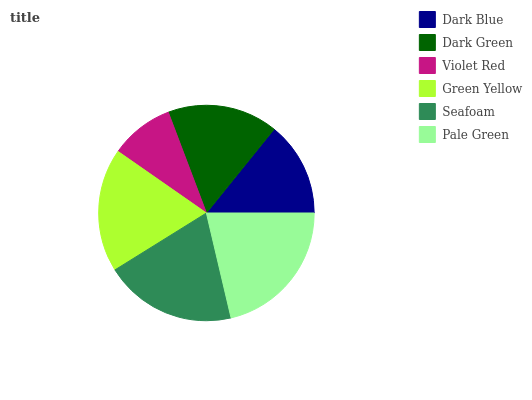Is Violet Red the minimum?
Answer yes or no. Yes. Is Pale Green the maximum?
Answer yes or no. Yes. Is Dark Green the minimum?
Answer yes or no. No. Is Dark Green the maximum?
Answer yes or no. No. Is Dark Green greater than Dark Blue?
Answer yes or no. Yes. Is Dark Blue less than Dark Green?
Answer yes or no. Yes. Is Dark Blue greater than Dark Green?
Answer yes or no. No. Is Dark Green less than Dark Blue?
Answer yes or no. No. Is Green Yellow the high median?
Answer yes or no. Yes. Is Dark Green the low median?
Answer yes or no. Yes. Is Pale Green the high median?
Answer yes or no. No. Is Green Yellow the low median?
Answer yes or no. No. 